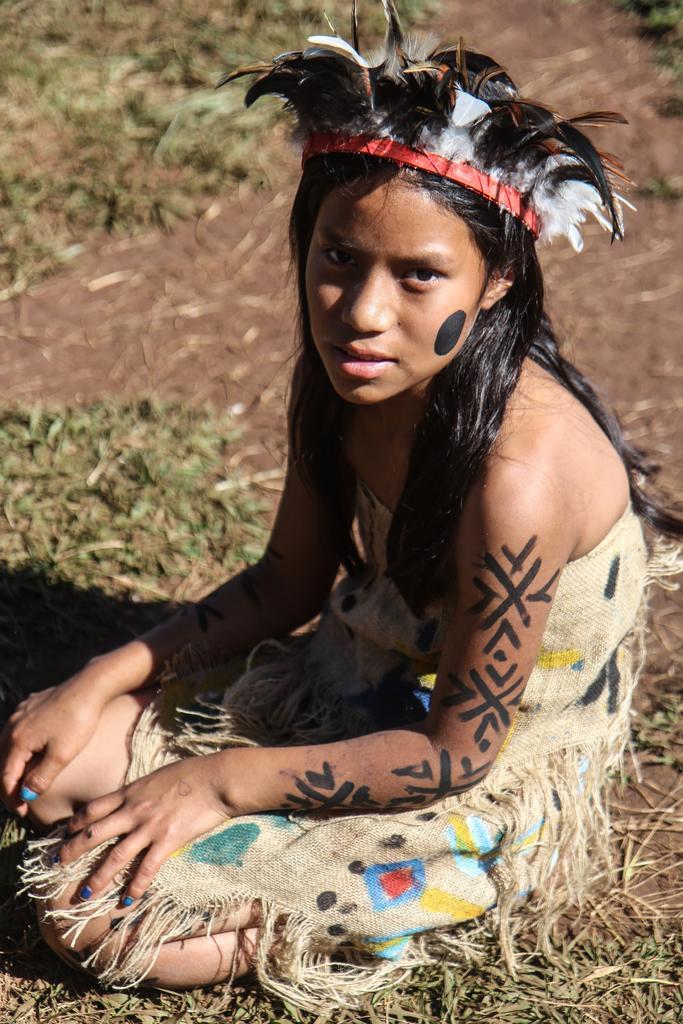How would you summarize this image in a sentence or two? In this image I can see a person sitting and the person is wearing cream color dress, background the grass is in green color. 